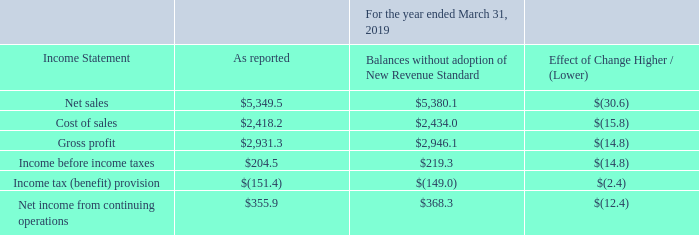Recently Adopted Accounting Pronouncements
On April 1, 2018, the Company adopted ASU 2014-09-Revenue from Contracts with Customers (ASC 606) and all related amendments (“New Revenue Standard”) using the modified retrospective method. The Company has applied the new revenue standard to all contracts that were entered into after adoption and to all contracts that were open as of the initial date of adoption. The Company recognized the cumulative effect of initially applying the new revenue standard as an adjustment to the opening balance of retained earnings. The comparative information has not been restated and continues to be reported under the accounting standards in effect for those periods. The adoption of the new standard impacts the Company's net sales on an ongoing basis depending on the relative amount of revenue sold through its distributors, the change in inventory held by its distributors, and the changes in price concessions granted to its distributors. Previously, the Company deferred revenue and cost of sales on shipments to distributors until the distributor sold the product to their end customer. As required by the new revenue standard, the Company no longer defers revenue and cost of sales, but rather, estimates the effects of returns and allowances provided to distributors and records revenue at the time of sale to the distributor. Sales to non-distributor customers, under both the previous and new revenue standards, are generally recognized upon the Company’s shipment of the product. The cumulative effect of the changes made to the consolidated April 1, 2018 balance sheet for the adoption of the new revenue standard is summarized in the table of opening balance sheet adjustments below. In accordance with the new revenue standard requirements, the disclosure of the impact of adoption on the consolidated income statement and balance sheet for the period ended March 31, 2019 was as follows (in millions):
The significant changes in the financial statements noted in the table above are primarily due to the transition from sellthrough revenue recognition to sell-in revenue recognition as required by the New Revenue Standard, which eliminated the balance of deferred income on shipments to distributors, significantly reduced accounts receivable, and significantly increased retained earnings. Prior to the acquisition of Microsemi, Microsemi already recognized revenue on a sell-in basis, so the impact of the adoption of the New Revenue Standard was primarily driven by Microchip's historical business excluding Microsemi.
What was the reported net sales?
Answer scale should be: million. 5,349.5. What was the change in cost of sales due to the standard?
Answer scale should be: million. (15.8). What was the Balances without adoption of New Revenue Standard for gross profit?
Answer scale should be: million. 2,946.1. What was the difference in amount as reported between net sales and cost of sales?
Answer scale should be: million. 5,349.5-2,418.2
Answer: 2931.3. What was the difference between Net income from continuing operations and Income before income taxes?
Answer scale should be: million. 355.9-204.5
Answer: 151.4. Which reported amounts exceeded $3,000 million? (Net sales:5,349.5)
Answer: net sales. 